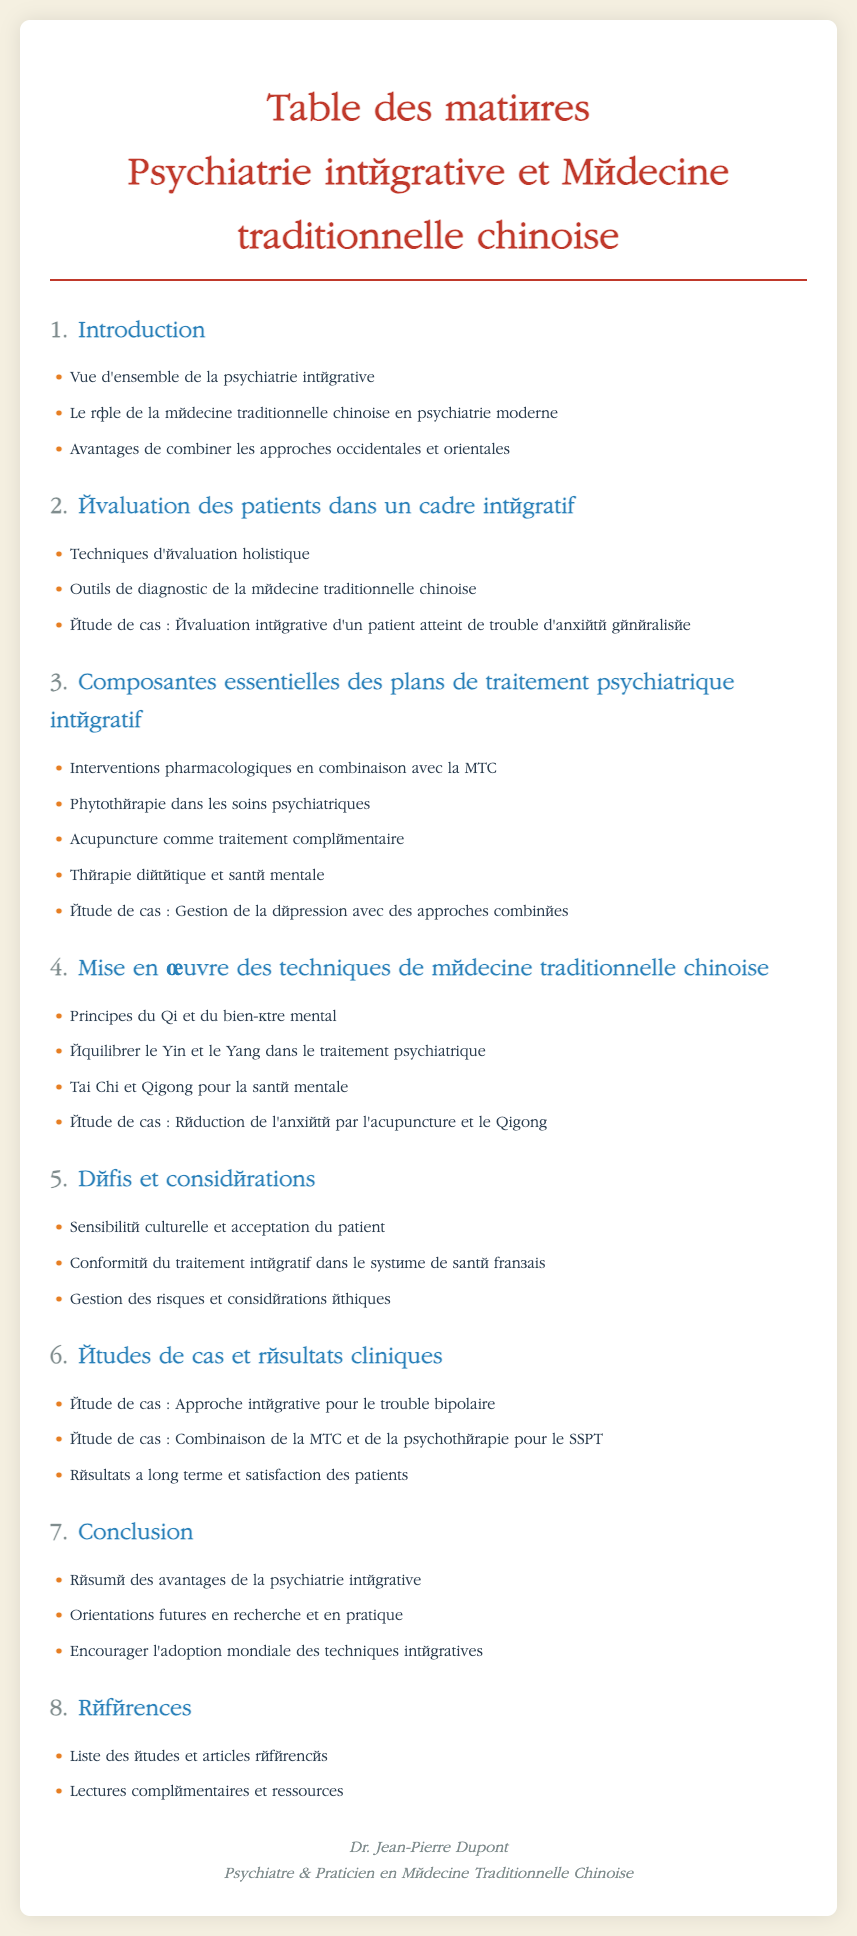Quel est le titre du document ? Le titre du document est mentionné au début, indiquant le sujet principal.
Answer: Table des matières - Psychiatrie intégrative et Médecine traditionnelle chinoise Combien de sections sont présentes dans le document ? Les sections sont numérotées dans la table des matières, indiquant le total.
Answer: 8 Quel est le thème de la première section ? La première section aborde le sujet principal du document, décrit en trois points.
Answer: Introduction Quelle technique est mentionnée comme traitement complémentaire dans la troisième section ? La troisième section liste plusieurs traitements, y compris celui-ci.
Answer: Acupuncture Quel est le principal défi discuté dans la cinquième section ? Le défi est décrit comme un problème potentiel lors de l'application des techniques intégratives.
Answer: Sensibilité culturelle et acceptation du patient Quel type d'étude de cas est présenté dans la quatrième section ? La quatrième section décrit une étude de cas spécifique à un problème de santé mentale.
Answer: Réduction de l'anxiété par l'acupuncture et le Qigong Quel est le contenu de la dernière section ? La dernière section inclut des éléments importants tels que des études et articles.
Answer: Références Qui est l'auteur du document ? L'auteur est mentionné à la fin dans la section de pied de page.
Answer: Dr. Jean-Pierre Dupont 